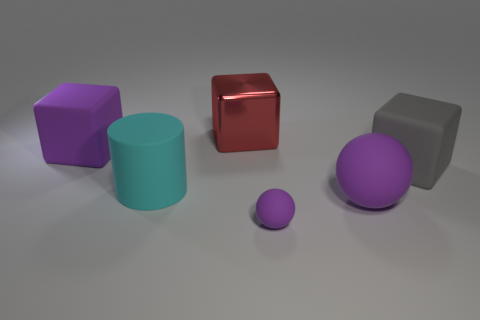Is there anything else that is the same material as the large red cube?
Give a very brief answer. No. What is the size of the purple object that is the same shape as the big gray thing?
Ensure brevity in your answer.  Large. Are there more large things that are on the left side of the big sphere than red rubber things?
Provide a succinct answer. Yes. Do the large block right of the red block and the red thing have the same material?
Offer a terse response. No. How big is the purple thing in front of the large purple rubber thing to the right of the purple thing that is to the left of the large cyan matte cylinder?
Ensure brevity in your answer.  Small. There is a cyan cylinder that is made of the same material as the gray cube; what size is it?
Provide a short and direct response. Large. There is a thing that is in front of the cyan object and behind the tiny matte ball; what color is it?
Make the answer very short. Purple. Do the purple matte object that is on the left side of the red shiny cube and the small thing that is right of the red thing have the same shape?
Give a very brief answer. No. What material is the sphere that is behind the small purple thing?
Provide a short and direct response. Rubber. The rubber block that is the same color as the tiny ball is what size?
Offer a terse response. Large. 